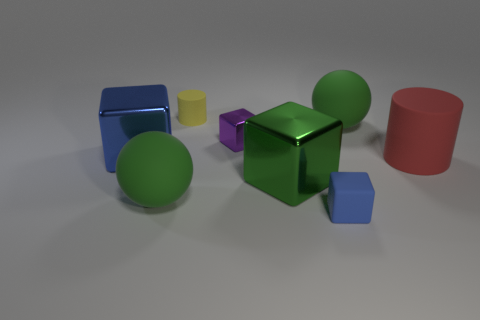Subtract all blue metal cubes. How many cubes are left? 3 Subtract all purple cubes. How many cubes are left? 3 Add 2 big blue rubber cubes. How many objects exist? 10 Add 6 large green matte spheres. How many large green matte spheres exist? 8 Subtract 0 gray spheres. How many objects are left? 8 Subtract all balls. How many objects are left? 6 Subtract 1 blocks. How many blocks are left? 3 Subtract all gray cylinders. Subtract all gray balls. How many cylinders are left? 2 Subtract all cyan cubes. How many red cylinders are left? 1 Subtract all cyan cylinders. Subtract all matte balls. How many objects are left? 6 